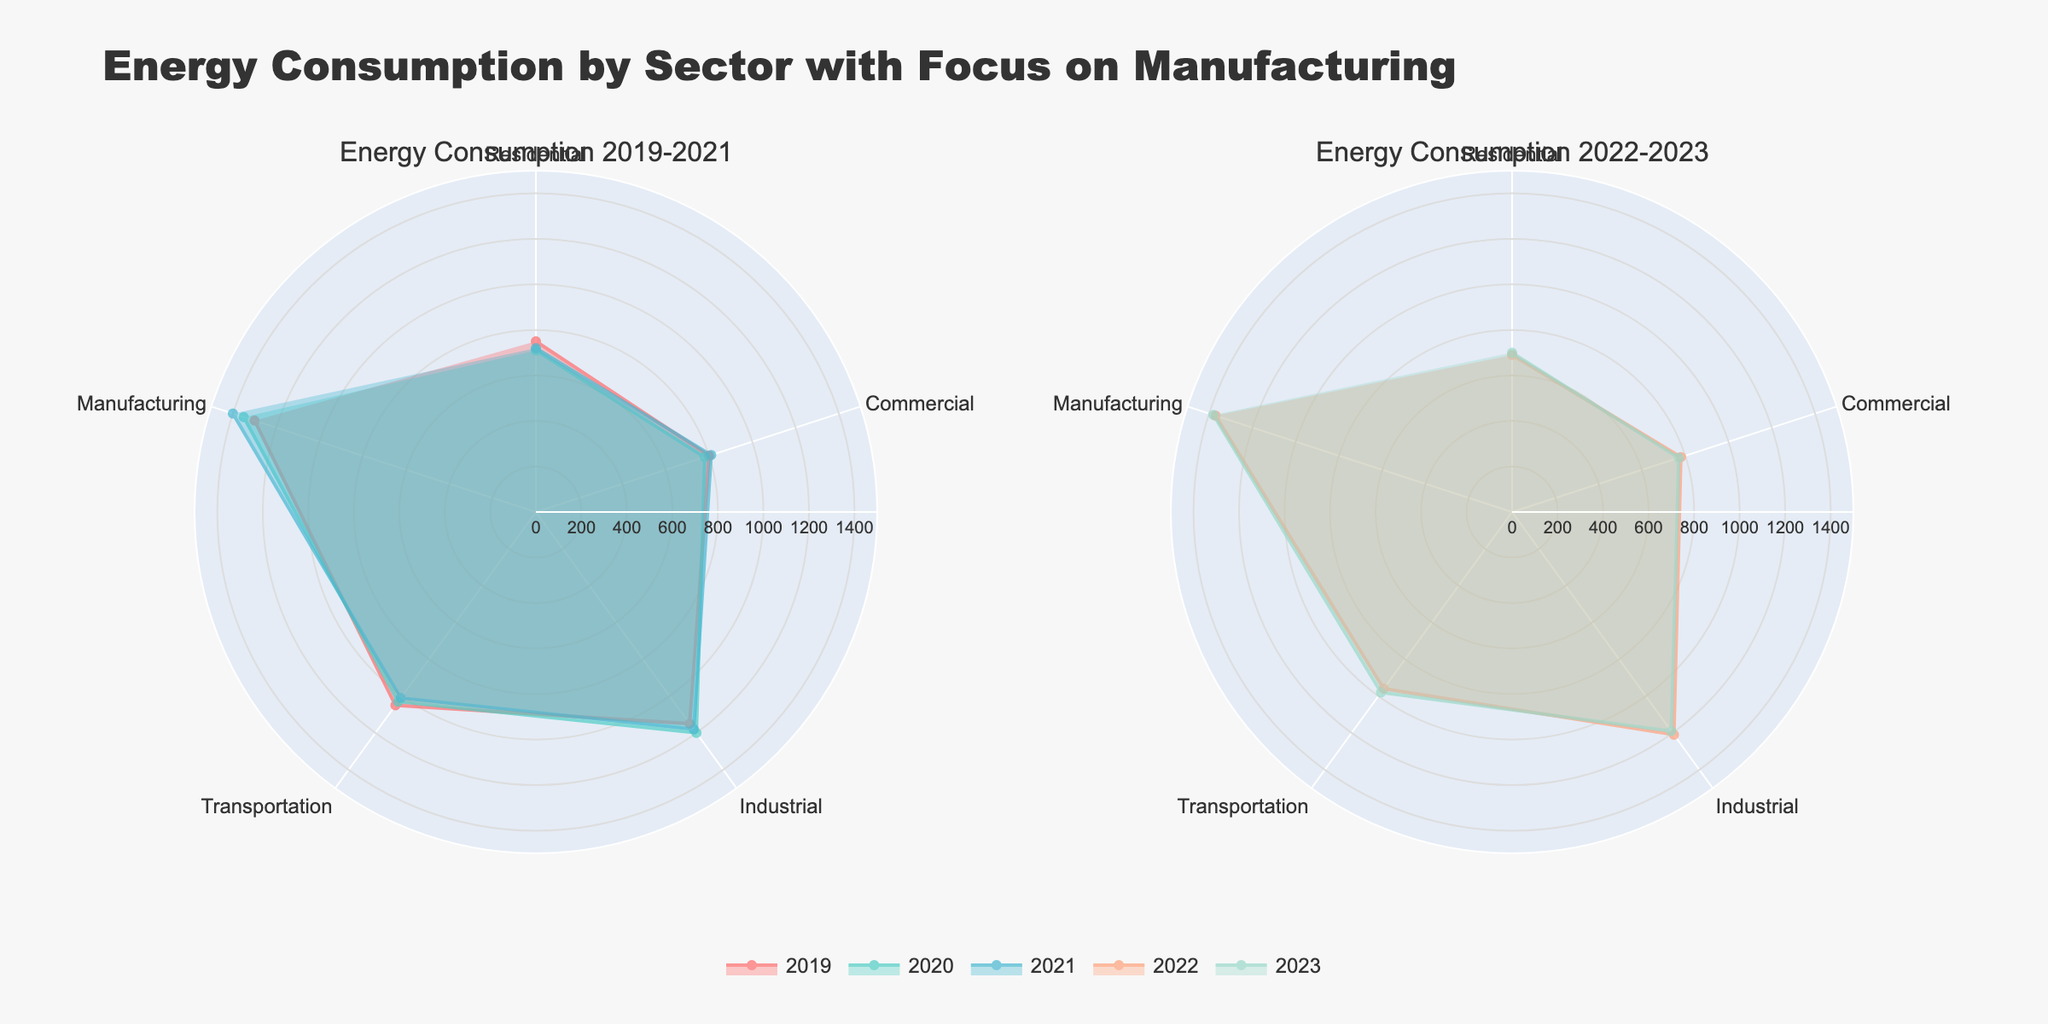What is the title of the figure? The title can be seen at the top of the figure. It reads "Energy Consumption by Sector with Focus on Manufacturing".
Answer: Energy Consumption by Sector with Focus on Manufacturing Which sector had the highest energy consumption in 2023? By looking at the lengths of the points extending from the center for each sector, you can see that Manufacturing has the longest indicator in 2023.
Answer: Manufacturing What are the sectors represented in the radar chart? The labels around the radar charts indicate the sectors being analyzed. They are Residential, Commercial, Industrial, Transportation, and Manufacturing.
Answer: Residential, Commercial, Industrial, Transportation, Manufacturing How did energy consumption change for the Manufacturing sector from 2019 to 2021? By following the trace of Manufacturing on the chart for the years 2019 to 2021, we see that energy consumption increased from 1300 in 2019, to 1350 in 2020, and then to 1400 in 2021.
Answer: Increased What is the difference in energy consumption for the Industrial sector between 2020 and 2023? We can compare the points for the Industrial sector at 2020 and 2023 in the second subplot. The energy consumption in 2020 was 1200 and in 2023 it was 1190. The difference is 1200 - 1190 = 10.
Answer: 10 Which year had the highest overall energy consumption for the Transportation sector? By comparing the radial lengths for Transportation across all years, we see that 2019 has the longest, indicating the highest energy consumption for that year.
Answer: 2019 Was the energy consumption for the Residential sector higher in 2021 or 2023? Looking at the radial positions for Residential in both subplots, it's clear that 2021 had a slightly higher value (720) than 2023 (700).
Answer: 2021 In the second subplot, which sector increased in energy consumption from 2022 to 2023? Comparing the radial lengths for each sector between 2022 and 2023, the Manufacturing sector shows an increase from 1370 to 1380.
Answer: Manufacturing What is the average energy consumption for the Manufacturing sector from 2019 to 2023? By adding up the energy consumption for Manufacturing for each year (1300 + 1350 + 1400 + 1370 + 1380) and dividing by 5, we get an average of 1360.
Answer: 1360 